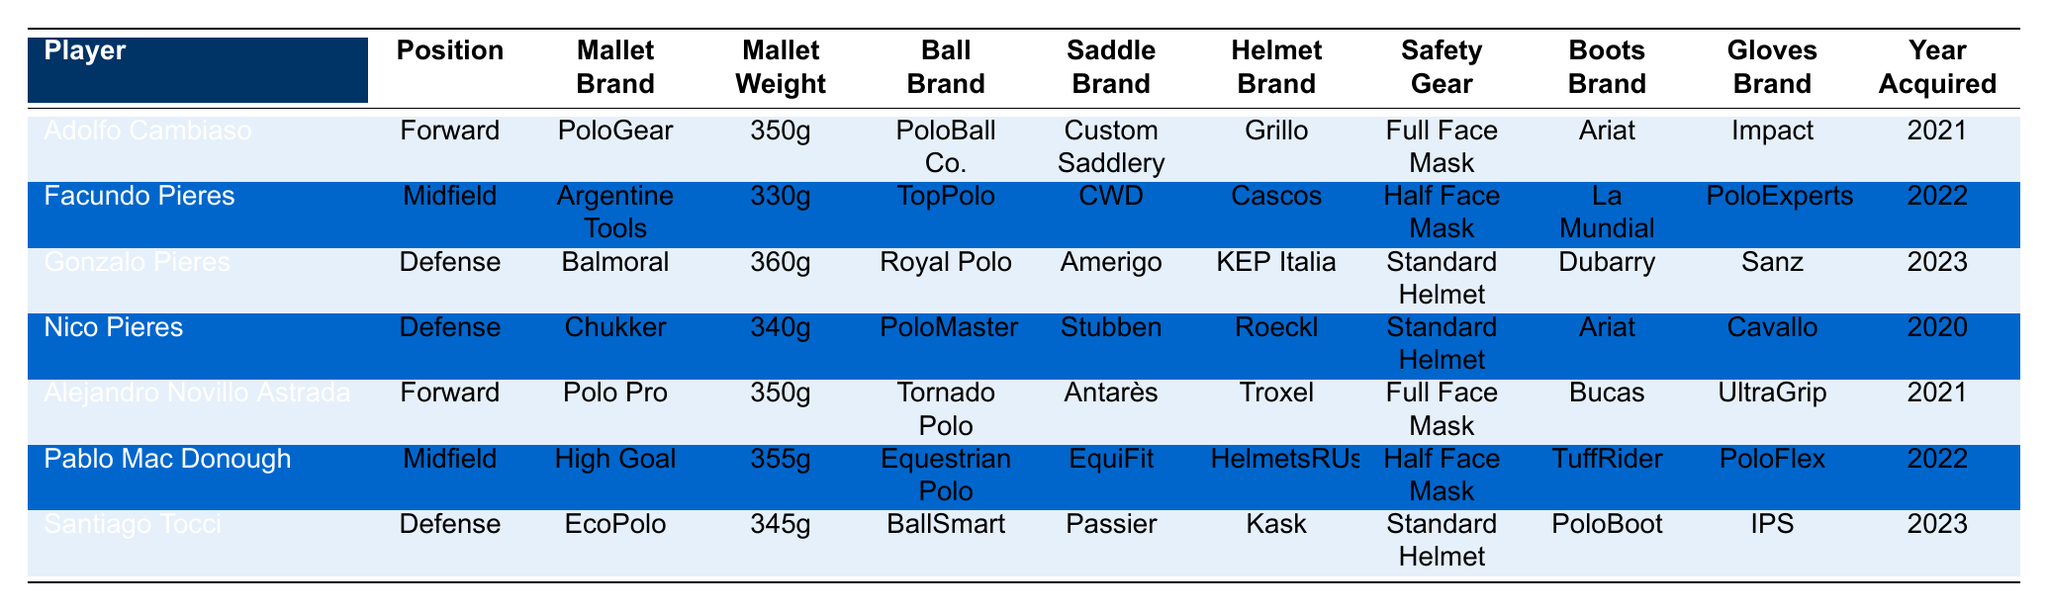What brand of mallet is used by Gonzalo Pieres? According to the table, Gonzalo Pieres uses a mallet from the brand Balmoral.
Answer: Balmoral Which player has the heaviest mallet? The table indicates that Gonzalo Pieres has the heaviest mallet, weighing 360g.
Answer: Gonzalo Pieres How many players use a full face mask as safety gear? In the table, Adolfo Cambiaso and Alejandro Novillo Astrada are listed as using full face masks, totaling two players.
Answer: 2 What is the average weight of the mallets used by players in the Forward position? Adolfo Cambiaso and Alejandro Novillo Astrada are both forwards with mallets weighing 350g. The average weight is (350 + 350) / 2 = 350g.
Answer: 350g Are there more midfield players or defense players listed in the table? The table shows three defense players (Gonzalo Pieres, Nico Pieres, and Santiago Tocci) and two midfield players (Facundo Pieres and Pablo Mac Donough), so there are more defense players.
Answer: Yes What brands of helmets are used by players acquired in 2022? Facundo Pieres uses Cascos, and Pablo Mac Donough uses HelmetsRUs, both players acquired their equipment in 2022.
Answer: Cascos and HelmetsRUs What is the total number of years since equipment acquisition for all players? The years since acquisition are 2 years (2023) + 1 year (2022) + 2 years (2021) + 3 years (2021) + 1 year (2022) + 3 years (2020) + 0 years (2023). Adding the year differences gives a total of 12 years.
Answer: 12 years Which player has the lightest mallet among all? Nico Pieres has the lightest mallet at 330g according to the table.
Answer: Nico Pieres Does any player use a helmet brand that includes "Italia"? Yes, the player Gonzalo Pieres uses a helmet brand called KEP Italia.
Answer: Yes What is the position of the player who has the brand "High Goal" for their mallet? Pablo Mac Donough, who uses a mallet from the brand High Goal, plays the position of Midfield.
Answer: Midfield 